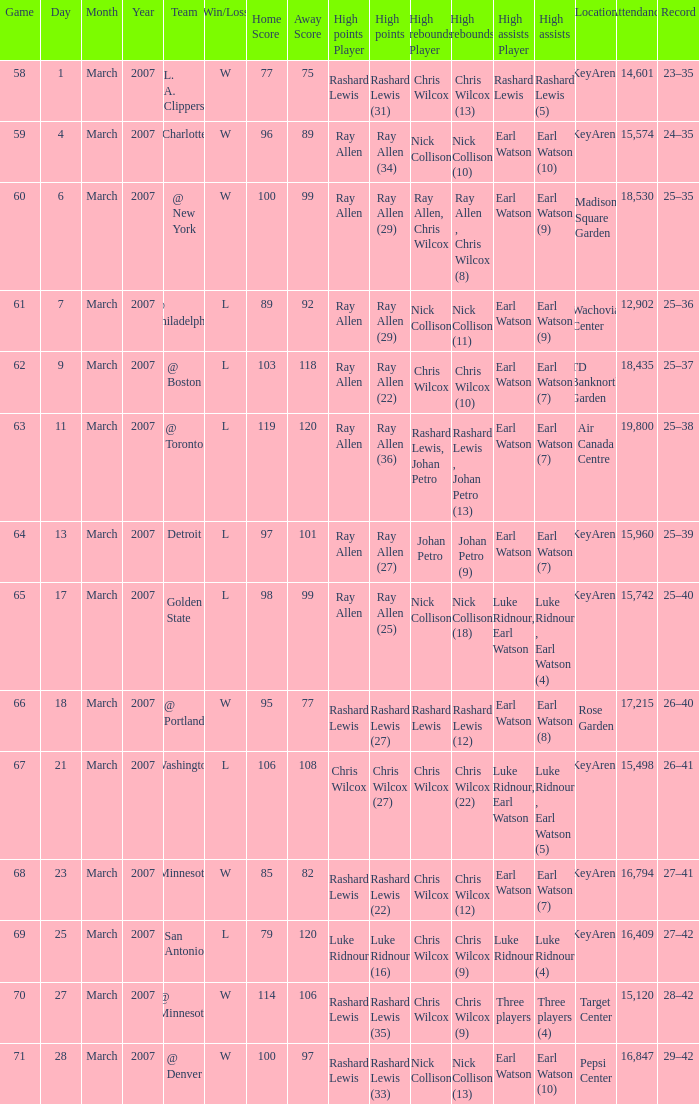What was the record after the game against Washington? 26–41. Could you help me parse every detail presented in this table? {'header': ['Game', 'Day', 'Month', 'Year', 'Team', 'Win/Loss', 'Home Score', 'Away Score', 'High points Player', 'High points', 'High rebounds Player', 'High rebounds', 'High assists Player', 'High assists', 'Location', 'Attendance', 'Record'], 'rows': [['58', '1', 'March', '2007', 'L. A. Clippers', 'W', '77', '75', 'Rashard Lewis', 'Rashard Lewis (31)', 'Chris Wilcox', 'Chris Wilcox (13)', 'Rashard Lewis', 'Rashard Lewis (5)', 'KeyArena', '14,601', '23–35'], ['59', '4', 'March', '2007', 'Charlotte', 'W', '96', '89', 'Ray Allen', 'Ray Allen (34)', 'Nick Collison', 'Nick Collison (10)', 'Earl Watson', 'Earl Watson (10)', 'KeyArena', '15,574', '24–35'], ['60', '6', 'March', '2007', '@ New York', 'W', '100', '99', 'Ray Allen', 'Ray Allen (29)', 'Ray Allen, Chris Wilcox', 'Ray Allen , Chris Wilcox (8)', 'Earl Watson', 'Earl Watson (9)', 'Madison Square Garden', '18,530', '25–35'], ['61', '7', 'March', '2007', '@ Philadelphia', 'L', '89', '92', 'Ray Allen', 'Ray Allen (29)', 'Nick Collison', 'Nick Collison (11)', 'Earl Watson', 'Earl Watson (9)', 'Wachovia Center', '12,902', '25–36'], ['62', '9', 'March', '2007', '@ Boston', 'L', '103', '118', 'Ray Allen', 'Ray Allen (22)', 'Chris Wilcox', 'Chris Wilcox (10)', 'Earl Watson', 'Earl Watson (7)', 'TD Banknorth Garden', '18,435', '25–37'], ['63', '11', 'March', '2007', '@ Toronto', 'L', '119', '120', 'Ray Allen', 'Ray Allen (36)', 'Rashard Lewis, Johan Petro', 'Rashard Lewis , Johan Petro (13)', 'Earl Watson', 'Earl Watson (7)', 'Air Canada Centre', '19,800', '25–38'], ['64', '13', 'March', '2007', 'Detroit', 'L', '97', '101', 'Ray Allen', 'Ray Allen (27)', 'Johan Petro', 'Johan Petro (9)', 'Earl Watson', 'Earl Watson (7)', 'KeyArena', '15,960', '25–39'], ['65', '17', 'March', '2007', 'Golden State', 'L', '98', '99', 'Ray Allen', 'Ray Allen (25)', 'Nick Collison', 'Nick Collison (18)', 'Luke Ridnour, Earl Watson', 'Luke Ridnour , Earl Watson (4)', 'KeyArena', '15,742', '25–40'], ['66', '18', 'March', '2007', '@ Portland', 'W', '95', '77', 'Rashard Lewis', 'Rashard Lewis (27)', 'Rashard Lewis', 'Rashard Lewis (12)', 'Earl Watson', 'Earl Watson (8)', 'Rose Garden', '17,215', '26–40'], ['67', '21', 'March', '2007', 'Washington', 'L', '106', '108', 'Chris Wilcox', 'Chris Wilcox (27)', 'Chris Wilcox', 'Chris Wilcox (22)', 'Luke Ridnour, Earl Watson', 'Luke Ridnour , Earl Watson (5)', 'KeyArena', '15,498', '26–41'], ['68', '23', 'March', '2007', 'Minnesota', 'W', '85', '82', 'Rashard Lewis', 'Rashard Lewis (22)', 'Chris Wilcox', 'Chris Wilcox (12)', 'Earl Watson', 'Earl Watson (7)', 'KeyArena', '16,794', '27–41'], ['69', '25', 'March', '2007', 'San Antonio', 'L', '79', '120', 'Luke Ridnour', 'Luke Ridnour (16)', 'Chris Wilcox', 'Chris Wilcox (9)', 'Luke Ridnour', 'Luke Ridnour (4)', 'KeyArena', '16,409', '27–42'], ['70', '27', 'March', '2007', '@ Minnesota', 'W', '114', '106', 'Rashard Lewis', 'Rashard Lewis (35)', 'Chris Wilcox', 'Chris Wilcox (9)', 'Three players', 'Three players (4)', 'Target Center', '15,120', '28–42'], ['71', '28', 'March', '2007', '@ Denver', 'W', '100', '97', 'Rashard Lewis', 'Rashard Lewis (33)', 'Nick Collison', 'Nick Collison (13)', 'Earl Watson', 'Earl Watson (10)', 'Pepsi Center', '16,847', '29–42']]} 